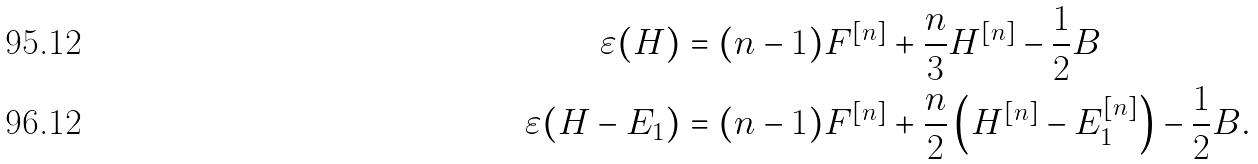Convert formula to latex. <formula><loc_0><loc_0><loc_500><loc_500>\varepsilon ( H ) & = ( n - 1 ) F ^ { [ n ] } + \frac { n } { 3 } H ^ { [ n ] } - \frac { 1 } { 2 } B \\ \varepsilon ( H - E _ { 1 } ) & = ( n - 1 ) F ^ { [ n ] } + \frac { n } { 2 } \left ( H ^ { [ n ] } - E _ { 1 } ^ { [ n ] } \right ) - \frac { 1 } { 2 } B .</formula> 